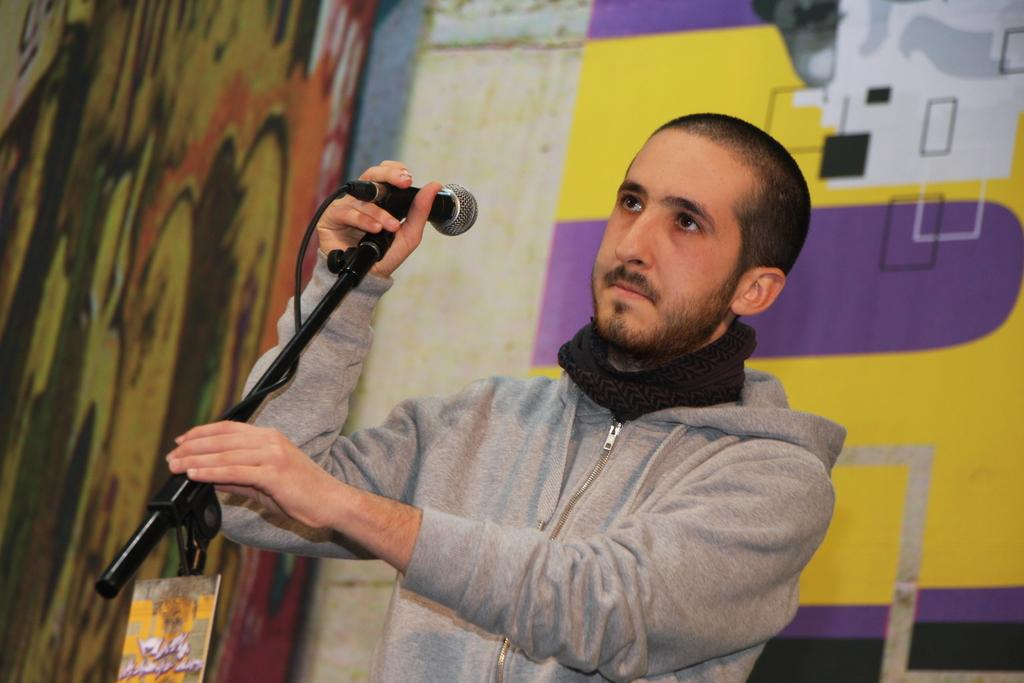Who is present in the image? There is a man in the image. What is the man wearing? The man is wearing a jacket. What is the man holding in his hands? The man is holding a microphone in his hands. In which direction is the man looking? The man is looking towards the left side. What can be seen in the background of the image? There is a wall in the background of the image. What type of powder is being used by the man in the image? There is no powder visible in the image; the man is holding a microphone. 